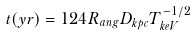<formula> <loc_0><loc_0><loc_500><loc_500>t ( y r ) = 1 2 4 { R } _ { a n g } { D } _ { k p c } { T } _ { k e V } ^ { - 1 / 2 }</formula> 